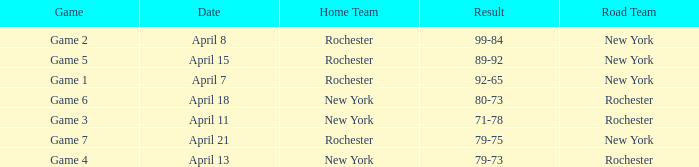Which Road Team has a Home Team of rochester, and a Game of game 2? New York. 